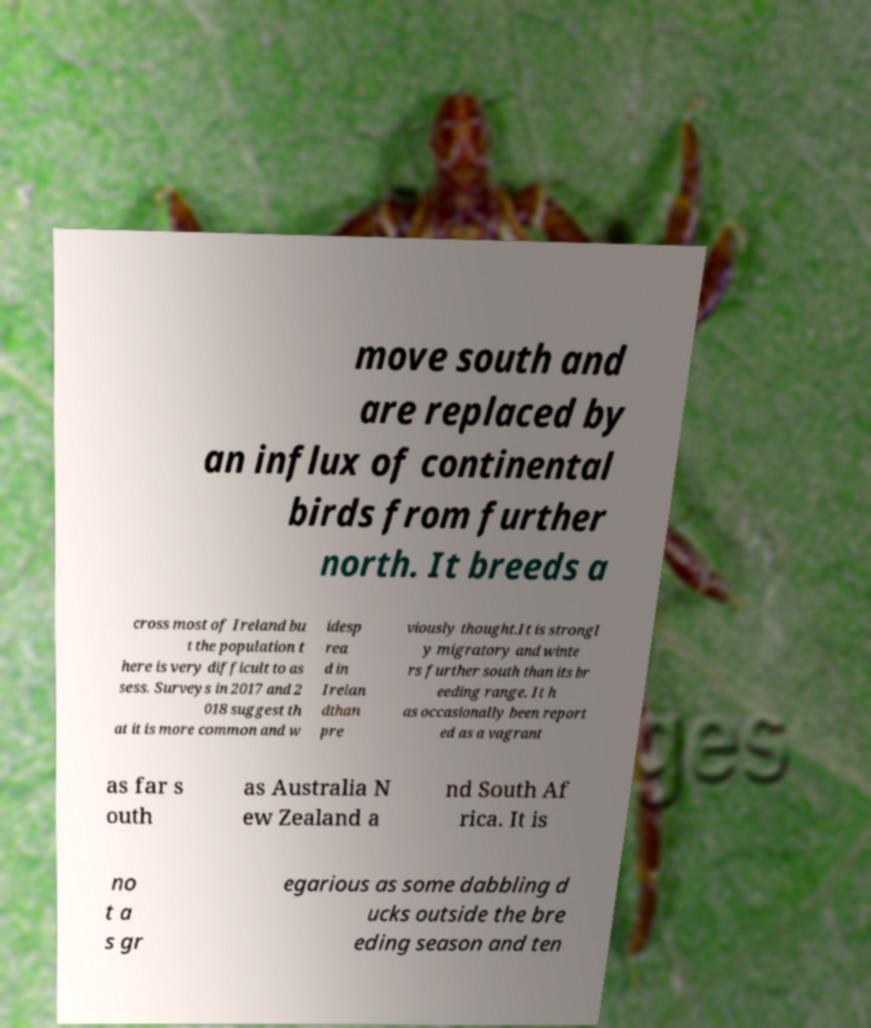Please read and relay the text visible in this image. What does it say? move south and are replaced by an influx of continental birds from further north. It breeds a cross most of Ireland bu t the population t here is very difficult to as sess. Surveys in 2017 and 2 018 suggest th at it is more common and w idesp rea d in Irelan dthan pre viously thought.It is strongl y migratory and winte rs further south than its br eeding range. It h as occasionally been report ed as a vagrant as far s outh as Australia N ew Zealand a nd South Af rica. It is no t a s gr egarious as some dabbling d ucks outside the bre eding season and ten 